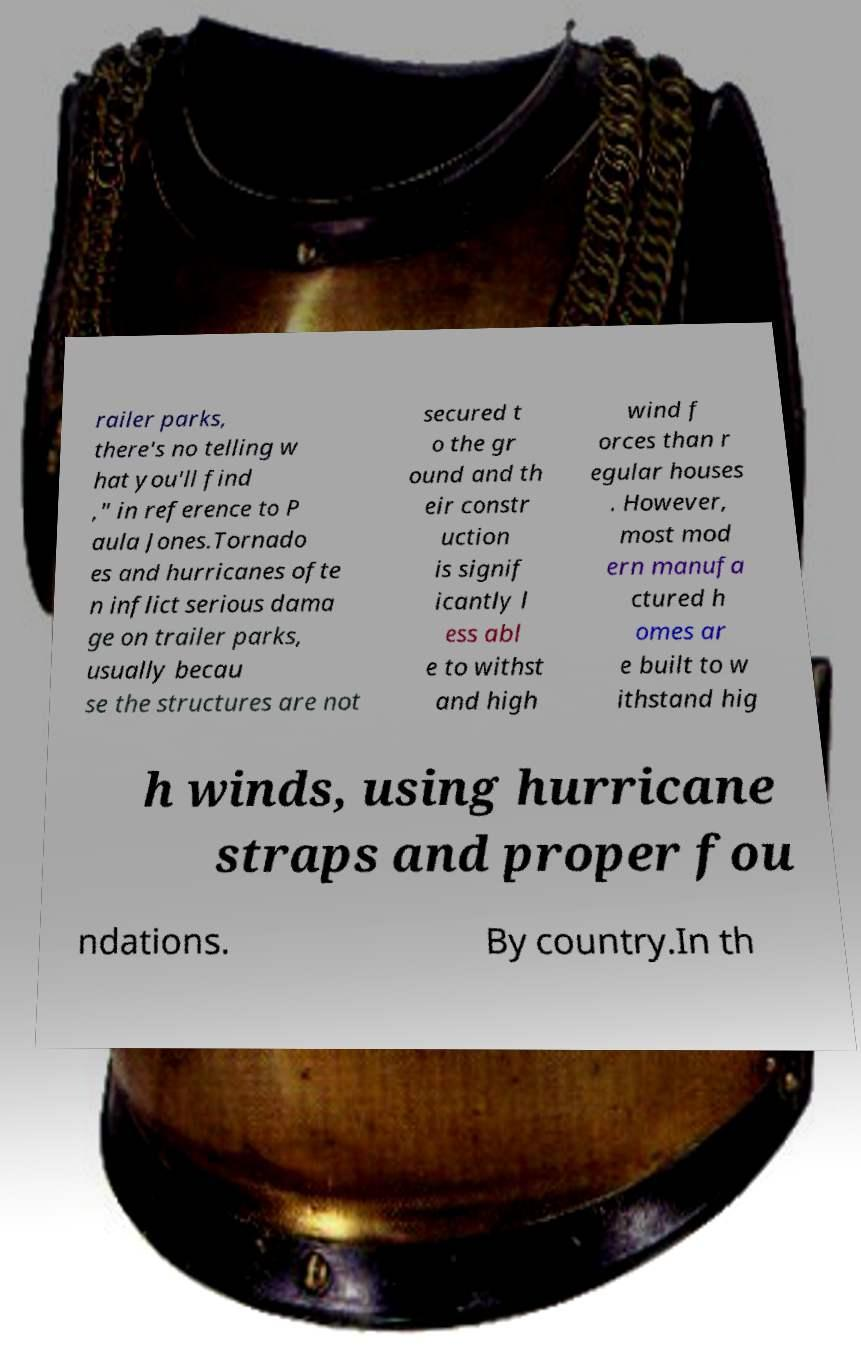What messages or text are displayed in this image? I need them in a readable, typed format. railer parks, there's no telling w hat you'll find ," in reference to P aula Jones.Tornado es and hurricanes ofte n inflict serious dama ge on trailer parks, usually becau se the structures are not secured t o the gr ound and th eir constr uction is signif icantly l ess abl e to withst and high wind f orces than r egular houses . However, most mod ern manufa ctured h omes ar e built to w ithstand hig h winds, using hurricane straps and proper fou ndations. By country.In th 